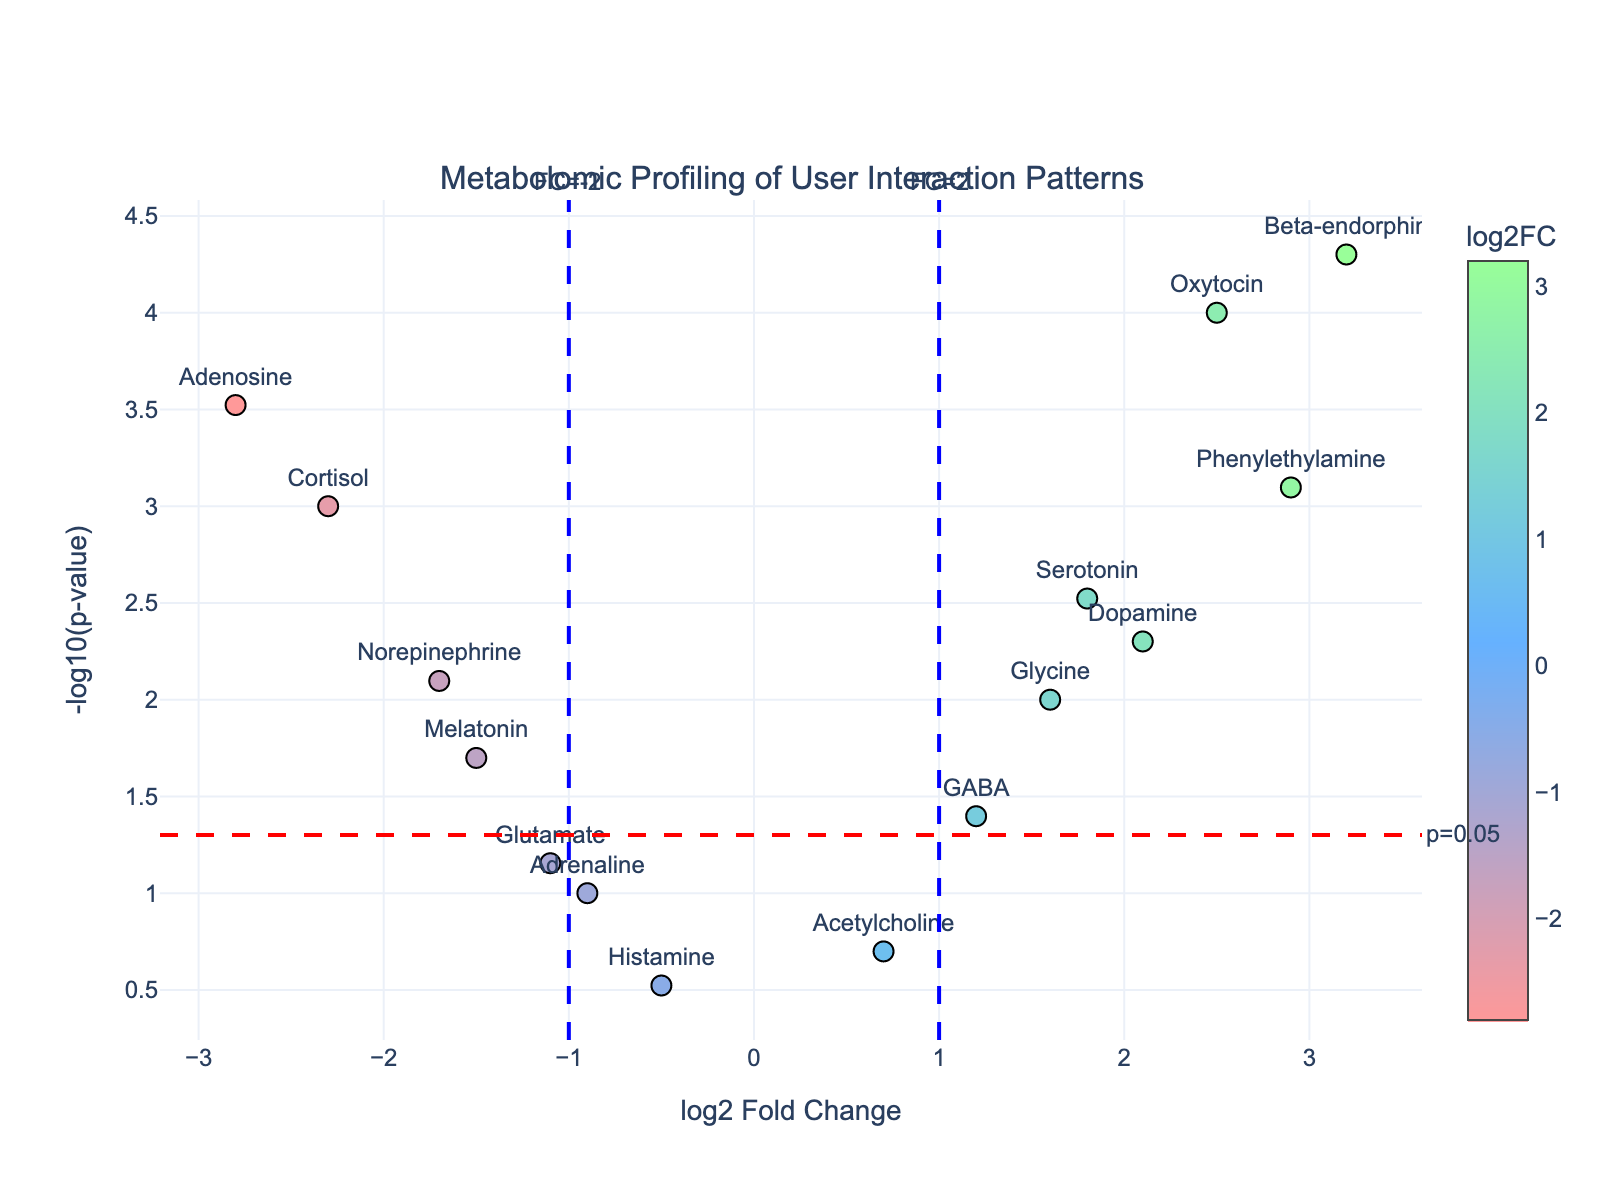What is the main title of the plot? The main title of a plot is usually displayed prominently at the top center of the figure. Looking at the plot, the title is "Metabolomic Profiling of User Interaction Patterns".
Answer: Metabolomic Profiling of User Interaction Patterns How many metabolites are shown in the plot? To determine the number of metabolites displayed, count the number of data points (markers) shown on the scatter plot. There are 15 data points, each representing a different metabolite.
Answer: 15 Which metabolite has the highest -log10(p-value)? Examine the y-axis for the point that is the highest on the plot. This would correspond to the metabolite with the highest -log10(p-value). The highest point is for "Beta-endorphin".
Answer: Beta-endorphin Which metabolite has a log2 fold change value closest to zero? Look for the data point that is nearest to the x-axis at log2FoldChange = 0. The metabolite with the log2 fold change value closest to zero is "Acetylcholine" with a value of 0.7.
Answer: Acetylcholine How many metabolites have a log2 fold change greater than 1? Count the data points positioned to the right of log2FoldChange = 1 on the plot. These metabolites include Serotonin, Dopamine, Oxytocin, Glycine, Beta-endorphin, and Phenylethylamine.
Answer: 6 Which metabolite is the most significantly downregulated? Downregulated metabolites have negative log2FoldChange values. The most significantly downregulated metabolite would be the one with the smallest (most negative) log2FoldChange value that is also significantly below the p-value threshold. "Adenosine" with log2FC = -2.8 and p-value = 0.0003 fits this criterion.
Answer: Adenosine Between Serotonin and Dopamine, which has a higher -log10(p-value)? Locate the positions of "Serotonin" and "Dopamine" on the plot. Compare their heights on the y-axis. "Serotonin" has a lower -log10(p-value) as it is positioned lower than "Dopamine" on the y-axis.
Answer: Dopamine Which metabolites are above the p-value significance threshold of 0.05? The p-value significance threshold is represented by the horizontal red dashed line. Identify the points above this line. Metabolites above this threshold include Cortisol, Serotonin, Dopamine, Norepinephrine, Oxytocin, Beta-endorphin, and Phenylethylamine.
Answer: Cortisol, Serotonin, Dopamine, Norepinephrine, Oxytocin, Beta-endorphin, Phenylethylamine Which metabolite is represented by the marker furthest to the left? Examine the plot for the marker located furthest to the left along the x-axis (log2FoldChange). The metabolite positioned here is "Adenosine".
Answer: Adenosine What is the log2 fold change value for Melatonin? Locate "Melatonin" on the plot to find its position along the x-axis. It has a log2FoldChange value of -1.5.
Answer: -1.5 